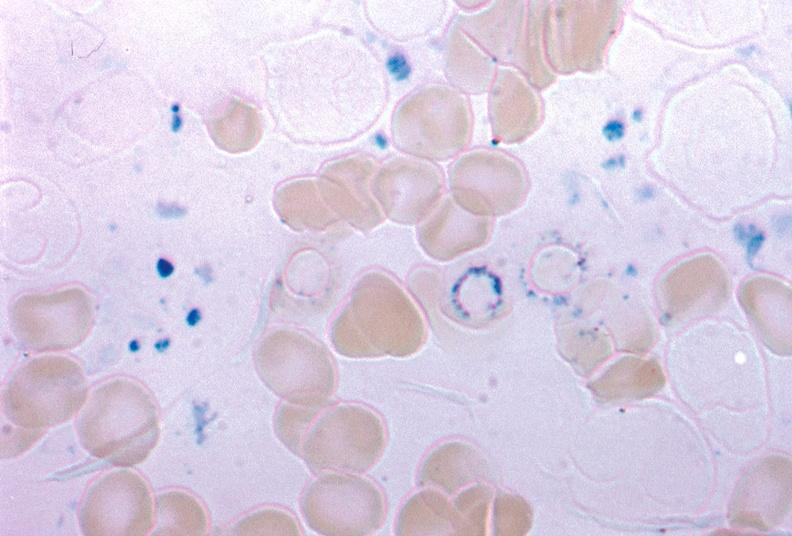does quite good liver stain excellent example source unknown?
Answer the question using a single word or phrase. No 